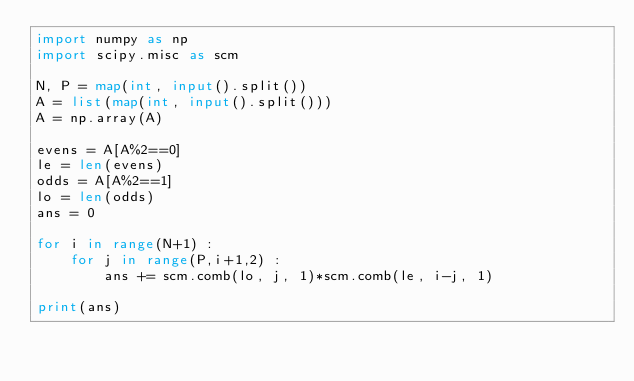Convert code to text. <code><loc_0><loc_0><loc_500><loc_500><_Python_>import numpy as np
import scipy.misc as scm

N, P = map(int, input().split())
A = list(map(int, input().split()))
A = np.array(A)

evens = A[A%2==0]
le = len(evens)
odds = A[A%2==1]
lo = len(odds)
ans = 0

for i in range(N+1) :
    for j in range(P,i+1,2) :
        ans += scm.comb(lo, j, 1)*scm.comb(le, i-j, 1)

print(ans)</code> 